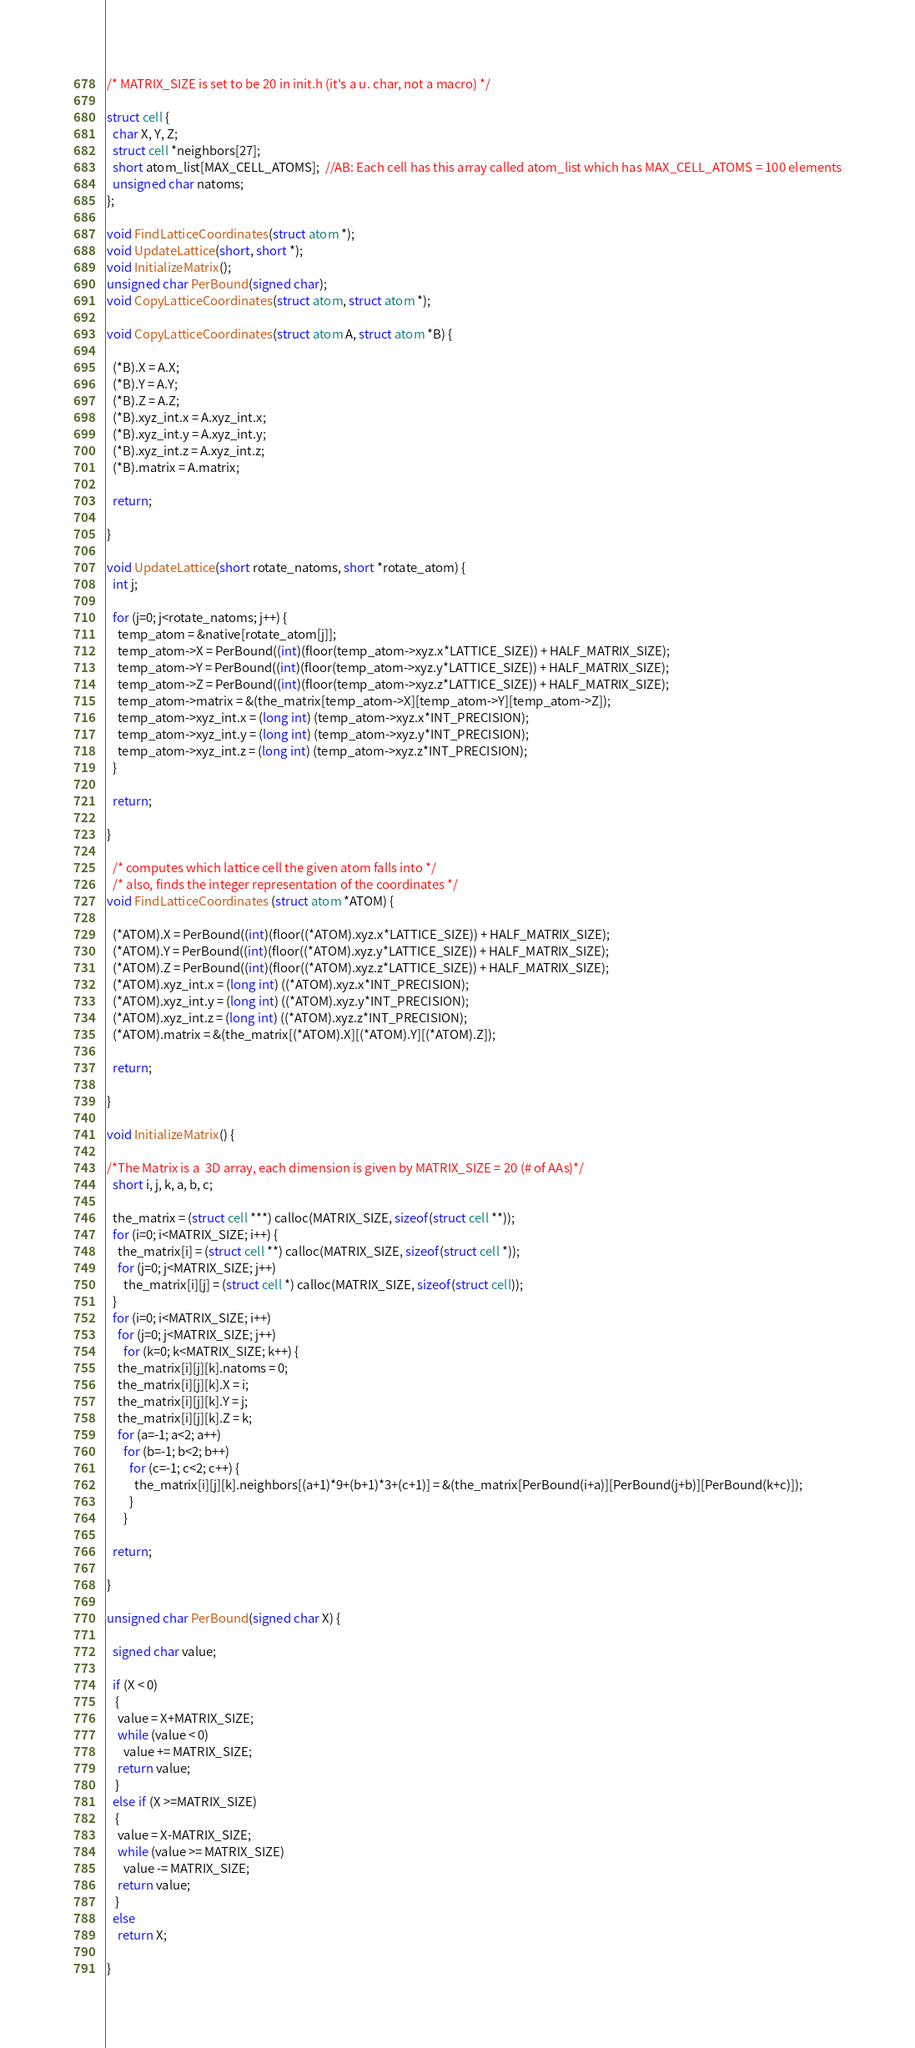Convert code to text. <code><loc_0><loc_0><loc_500><loc_500><_C_>/* MATRIX_SIZE is set to be 20 in init.h (it's a u. char, not a macro) */

struct cell {
  char X, Y, Z;
  struct cell *neighbors[27];
  short atom_list[MAX_CELL_ATOMS];  //AB: Each cell has this array called atom_list which has MAX_CELL_ATOMS = 100 elements
  unsigned char natoms;
};

void FindLatticeCoordinates(struct atom *);
void UpdateLattice(short, short *);
void InitializeMatrix();
unsigned char PerBound(signed char);
void CopyLatticeCoordinates(struct atom, struct atom *);

void CopyLatticeCoordinates(struct atom A, struct atom *B) {
  
  (*B).X = A.X;
  (*B).Y = A.Y;
  (*B).Z = A.Z;
  (*B).xyz_int.x = A.xyz_int.x;
  (*B).xyz_int.y = A.xyz_int.y;
  (*B).xyz_int.z = A.xyz_int.z;
  (*B).matrix = A.matrix;

  return;

}

void UpdateLattice(short rotate_natoms, short *rotate_atom) {
  int j;

  for (j=0; j<rotate_natoms; j++) {
    temp_atom = &native[rotate_atom[j]];
    temp_atom->X = PerBound((int)(floor(temp_atom->xyz.x*LATTICE_SIZE)) + HALF_MATRIX_SIZE);
    temp_atom->Y = PerBound((int)(floor(temp_atom->xyz.y*LATTICE_SIZE)) + HALF_MATRIX_SIZE);
    temp_atom->Z = PerBound((int)(floor(temp_atom->xyz.z*LATTICE_SIZE)) + HALF_MATRIX_SIZE);
    temp_atom->matrix = &(the_matrix[temp_atom->X][temp_atom->Y][temp_atom->Z]);
    temp_atom->xyz_int.x = (long int) (temp_atom->xyz.x*INT_PRECISION);
    temp_atom->xyz_int.y = (long int) (temp_atom->xyz.y*INT_PRECISION);
    temp_atom->xyz_int.z = (long int) (temp_atom->xyz.z*INT_PRECISION);
  }
 
  return;
  
}

  /* computes which lattice cell the given atom falls into */
  /* also, finds the integer representation of the coordinates */
void FindLatticeCoordinates (struct atom *ATOM) {

  (*ATOM).X = PerBound((int)(floor((*ATOM).xyz.x*LATTICE_SIZE)) + HALF_MATRIX_SIZE);
  (*ATOM).Y = PerBound((int)(floor((*ATOM).xyz.y*LATTICE_SIZE)) + HALF_MATRIX_SIZE);
  (*ATOM).Z = PerBound((int)(floor((*ATOM).xyz.z*LATTICE_SIZE)) + HALF_MATRIX_SIZE);
  (*ATOM).xyz_int.x = (long int) ((*ATOM).xyz.x*INT_PRECISION);
  (*ATOM).xyz_int.y = (long int) ((*ATOM).xyz.y*INT_PRECISION);
  (*ATOM).xyz_int.z = (long int) ((*ATOM).xyz.z*INT_PRECISION);
  (*ATOM).matrix = &(the_matrix[(*ATOM).X][(*ATOM).Y][(*ATOM).Z]);
  
  return;
  
}

void InitializeMatrix() {

/*The Matrix is a  3D array, each dimension is given by MATRIX_SIZE = 20 (# of AAs)*/
  short i, j, k, a, b, c;

  the_matrix = (struct cell ***) calloc(MATRIX_SIZE, sizeof(struct cell **));
  for (i=0; i<MATRIX_SIZE; i++) {
    the_matrix[i] = (struct cell **) calloc(MATRIX_SIZE, sizeof(struct cell *));
    for (j=0; j<MATRIX_SIZE; j++)
      the_matrix[i][j] = (struct cell *) calloc(MATRIX_SIZE, sizeof(struct cell));
  }  
  for (i=0; i<MATRIX_SIZE; i++)
    for (j=0; j<MATRIX_SIZE; j++)
      for (k=0; k<MATRIX_SIZE; k++) {
	the_matrix[i][j][k].natoms = 0;
	the_matrix[i][j][k].X = i;
	the_matrix[i][j][k].Y = j;
	the_matrix[i][j][k].Z = k;
	for (a=-1; a<2; a++)
	  for (b=-1; b<2; b++)
	    for (c=-1; c<2; c++) {
	      the_matrix[i][j][k].neighbors[(a+1)*9+(b+1)*3+(c+1)] = &(the_matrix[PerBound(i+a)][PerBound(j+b)][PerBound(k+c)]);
	    }
      }

  return;

}

unsigned char PerBound(signed char X) {
  
  signed char value;
  
  if (X < 0) 
   {
    value = X+MATRIX_SIZE;
    while (value < 0)
      value += MATRIX_SIZE;
    return value;
   }
  else if (X >=MATRIX_SIZE) 
   {
    value = X-MATRIX_SIZE;
    while (value >= MATRIX_SIZE)
      value -= MATRIX_SIZE;
    return value;
   }
  else
    return X;
  
}
</code> 